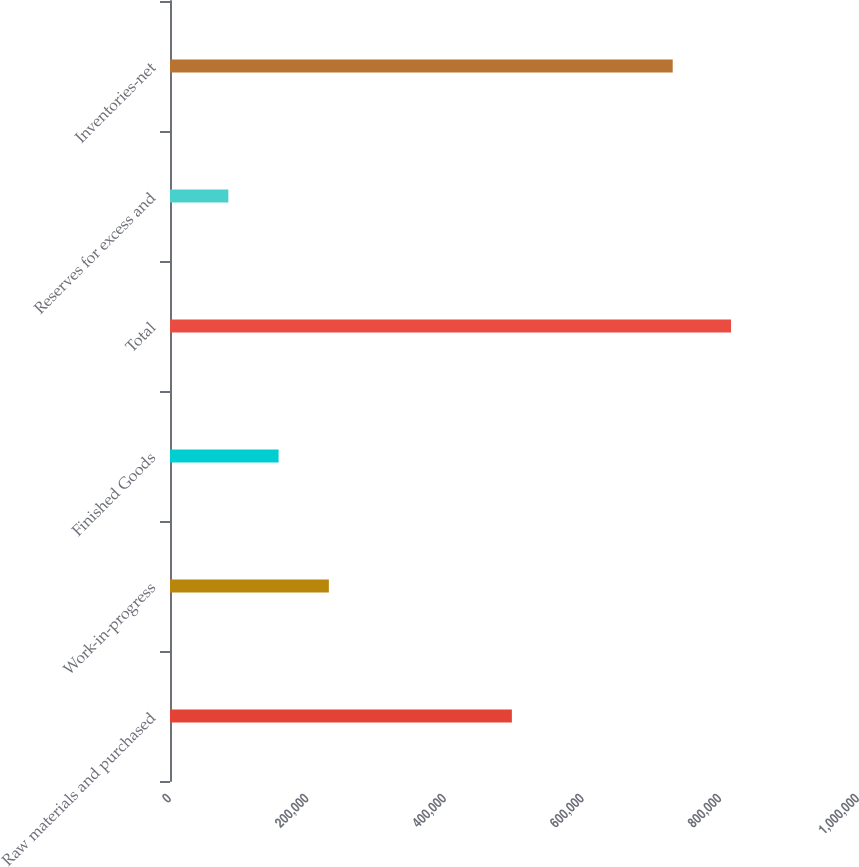Convert chart. <chart><loc_0><loc_0><loc_500><loc_500><bar_chart><fcel>Raw materials and purchased<fcel>Work-in-progress<fcel>Finished Goods<fcel>Total<fcel>Reserves for excess and<fcel>Inventories-net<nl><fcel>496899<fcel>230911<fcel>157843<fcel>815456<fcel>84775<fcel>730681<nl></chart> 